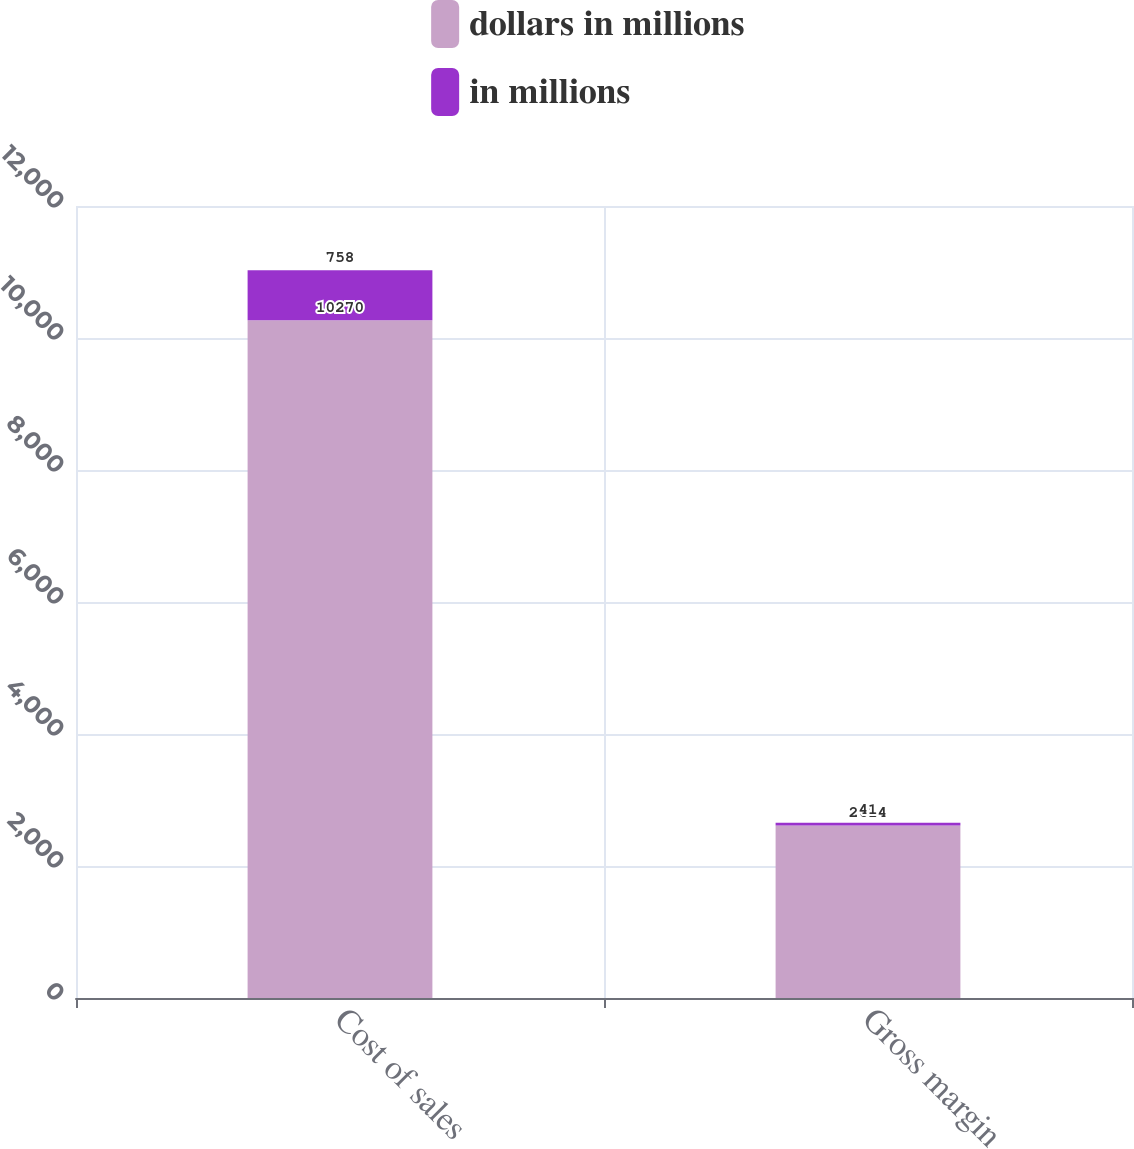Convert chart to OTSL. <chart><loc_0><loc_0><loc_500><loc_500><stacked_bar_chart><ecel><fcel>Cost of sales<fcel>Gross margin<nl><fcel>dollars in millions<fcel>10270<fcel>2614<nl><fcel>in millions<fcel>758<fcel>41<nl></chart> 